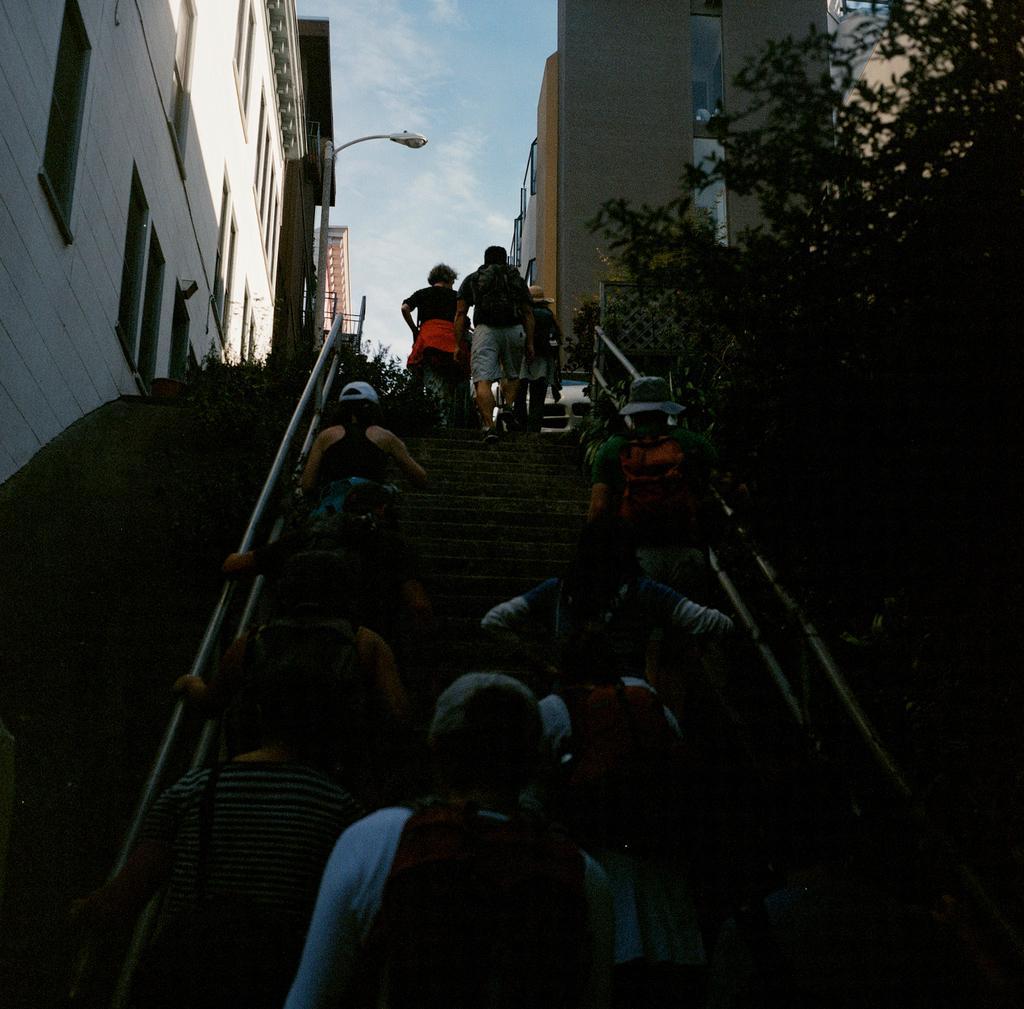Describe this image in one or two sentences. In the picture we can see some group of persons walking through the stairs and there are some trees, houses on left and right side of the picture. 